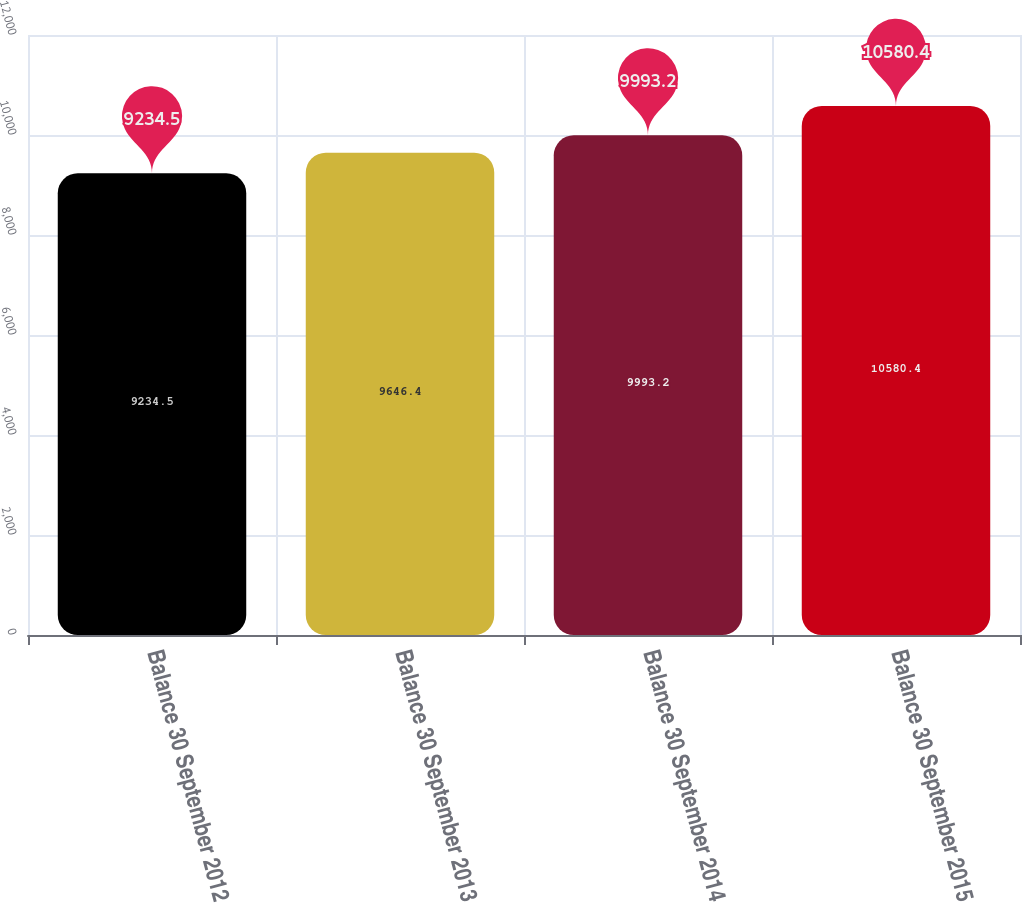Convert chart to OTSL. <chart><loc_0><loc_0><loc_500><loc_500><bar_chart><fcel>Balance 30 September 2012<fcel>Balance 30 September 2013<fcel>Balance 30 September 2014<fcel>Balance 30 September 2015<nl><fcel>9234.5<fcel>9646.4<fcel>9993.2<fcel>10580.4<nl></chart> 